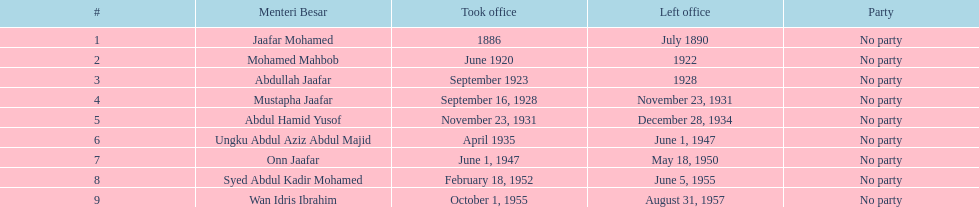Who succeeded onn jaafar in office? Syed Abdul Kadir Mohamed. 